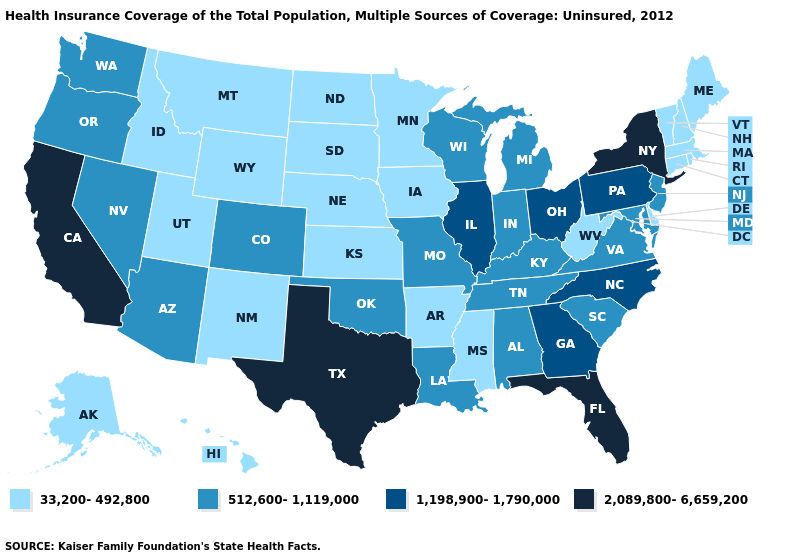Does Delaware have a lower value than Virginia?
Keep it brief. Yes. Which states have the lowest value in the West?
Answer briefly. Alaska, Hawaii, Idaho, Montana, New Mexico, Utah, Wyoming. Does the first symbol in the legend represent the smallest category?
Be succinct. Yes. Does Illinois have the highest value in the MidWest?
Keep it brief. Yes. What is the value of California?
Keep it brief. 2,089,800-6,659,200. Does Minnesota have a lower value than Maryland?
Answer briefly. Yes. How many symbols are there in the legend?
Be succinct. 4. What is the highest value in the USA?
Keep it brief. 2,089,800-6,659,200. Which states have the lowest value in the South?
Give a very brief answer. Arkansas, Delaware, Mississippi, West Virginia. How many symbols are there in the legend?
Quick response, please. 4. Which states hav the highest value in the MidWest?
Write a very short answer. Illinois, Ohio. Among the states that border Washington , does Idaho have the highest value?
Write a very short answer. No. Name the states that have a value in the range 512,600-1,119,000?
Write a very short answer. Alabama, Arizona, Colorado, Indiana, Kentucky, Louisiana, Maryland, Michigan, Missouri, Nevada, New Jersey, Oklahoma, Oregon, South Carolina, Tennessee, Virginia, Washington, Wisconsin. Does the map have missing data?
Concise answer only. No. Among the states that border New Jersey , which have the highest value?
Give a very brief answer. New York. 